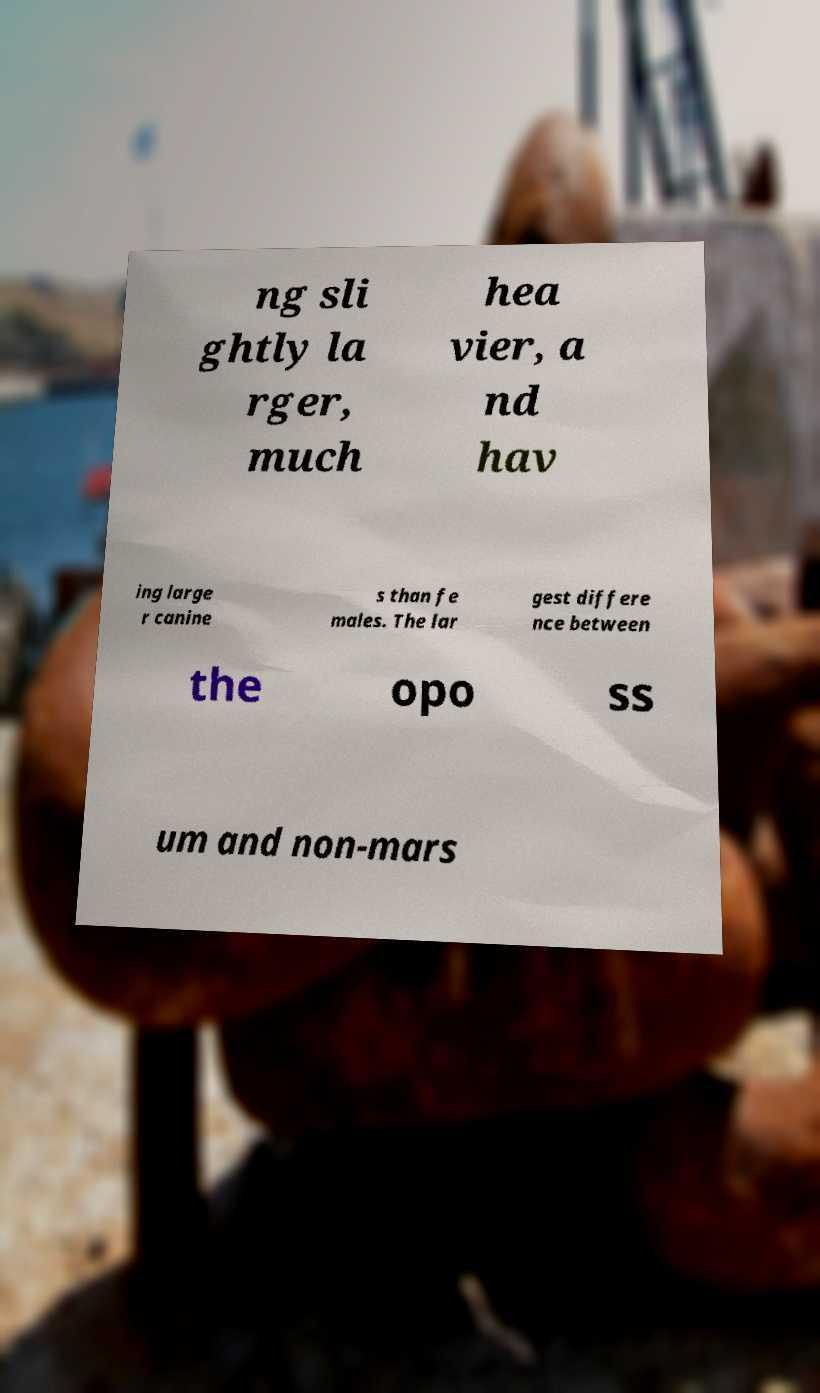Could you assist in decoding the text presented in this image and type it out clearly? ng sli ghtly la rger, much hea vier, a nd hav ing large r canine s than fe males. The lar gest differe nce between the opo ss um and non-mars 